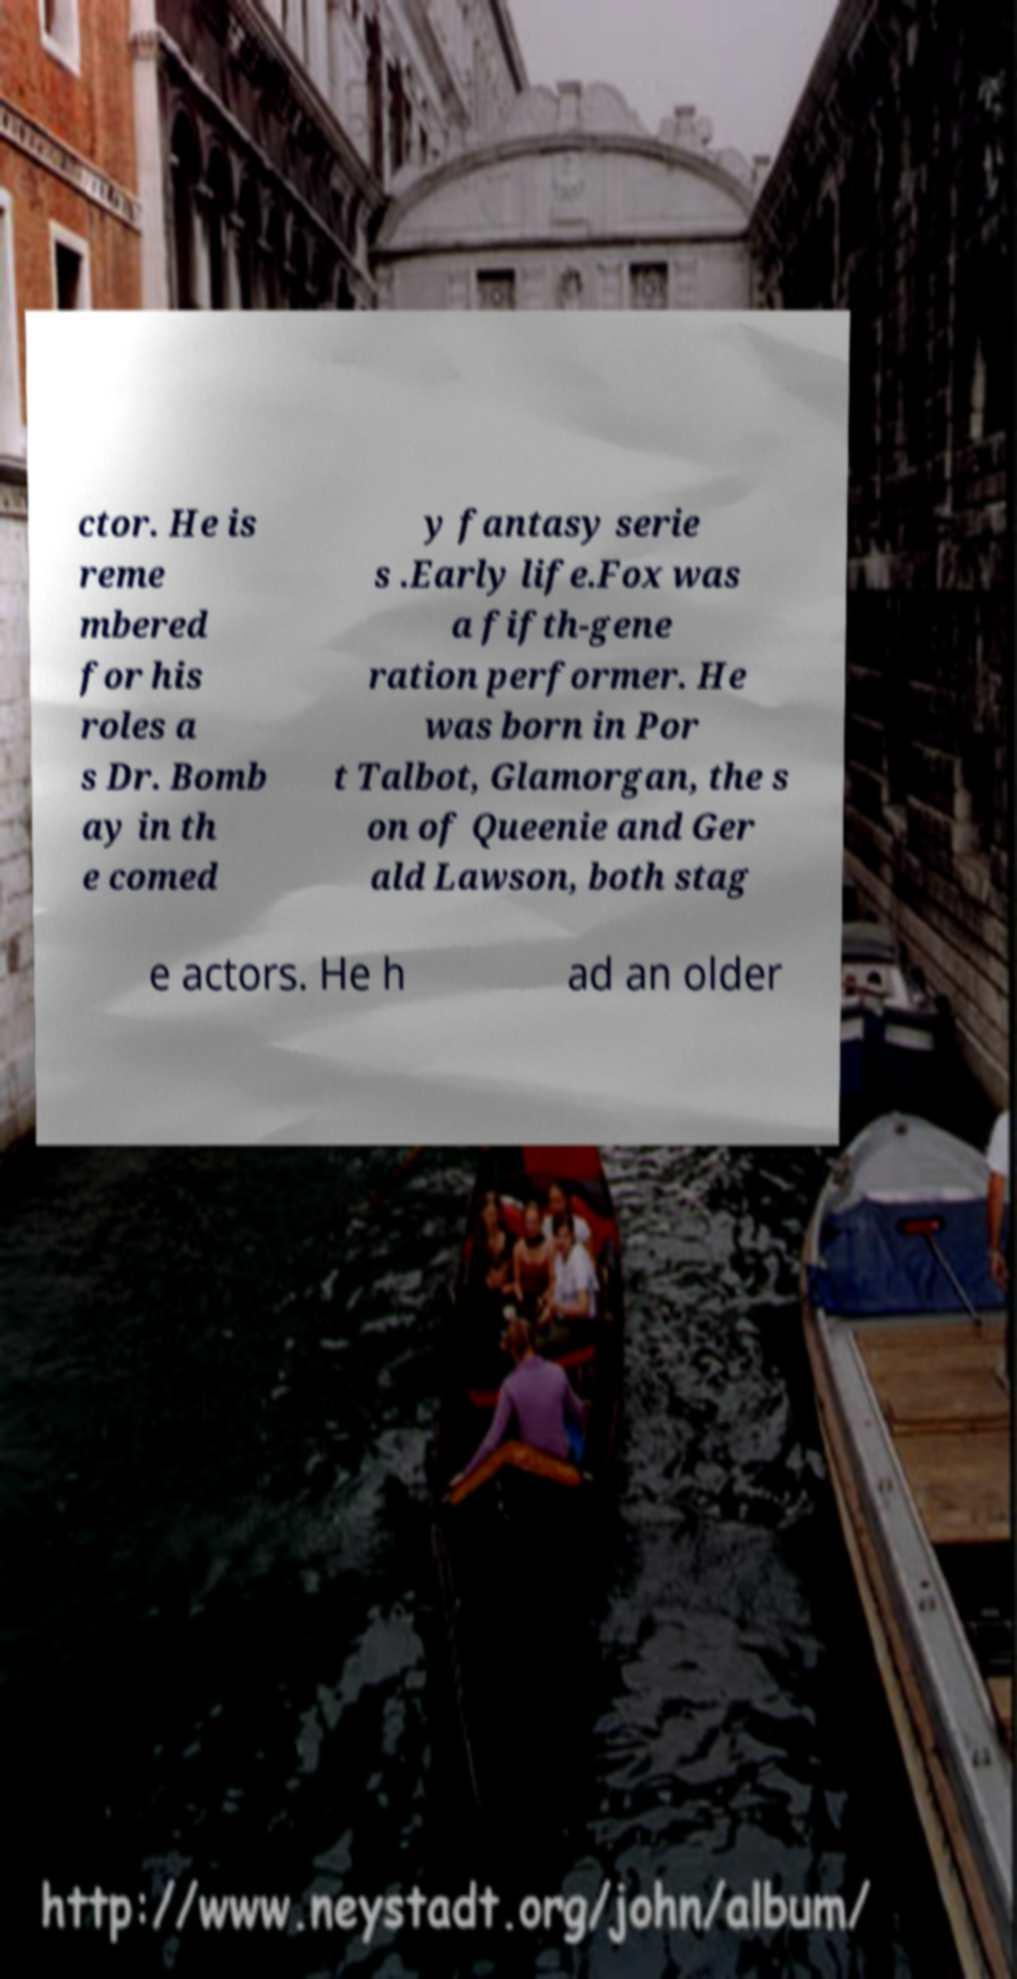Could you assist in decoding the text presented in this image and type it out clearly? ctor. He is reme mbered for his roles a s Dr. Bomb ay in th e comed y fantasy serie s .Early life.Fox was a fifth-gene ration performer. He was born in Por t Talbot, Glamorgan, the s on of Queenie and Ger ald Lawson, both stag e actors. He h ad an older 